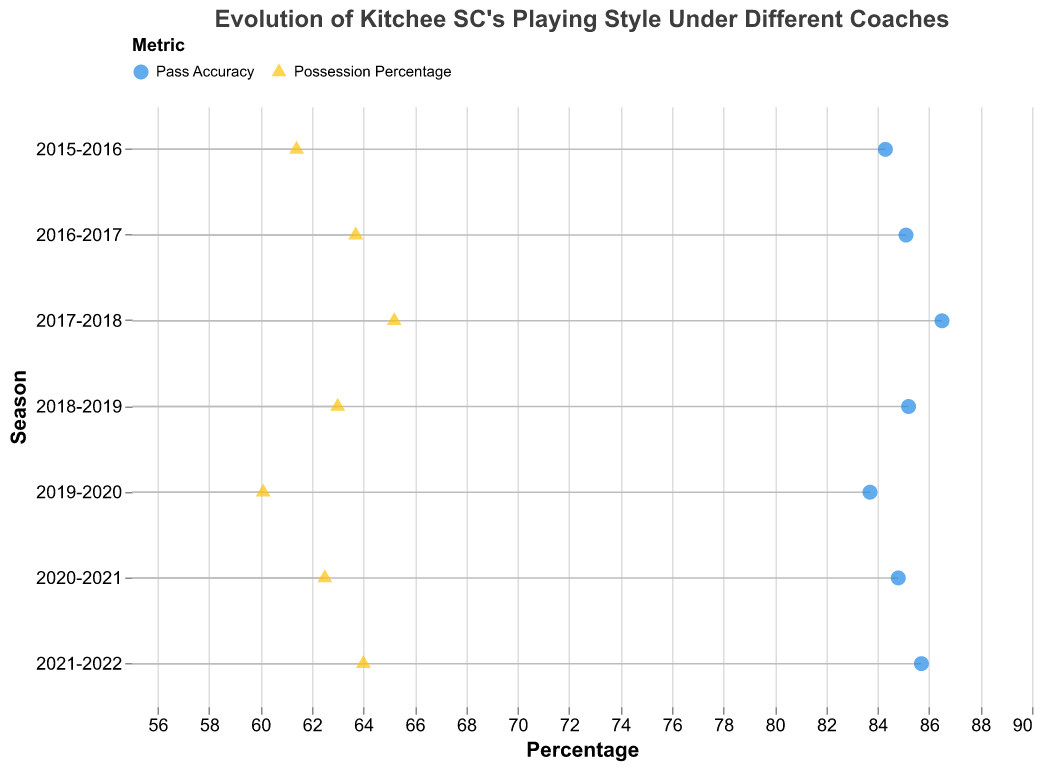What is the title of the figure? The title of a figure is usually found at the top and describes what the plot is about.
Answer: Evolution of Kitchee SC's Playing Style Under Different Coaches What are the two metrics visualized in the plot? From the legend or axis labels of the plot, we can identify the metrics being visualized.
Answer: Possession Percentage and Pass Accuracy In which season did Kitchee SC have the highest possession percentage, and who was the coach? Identify the data point with the highest possession percentage value and note the corresponding season and coach.
Answer: 2017-2018, Chu Chi Kwong What is the pass accuracy percentage for Alex Chu in the 2021-2022 season? Look at the data points for Alex Chu in the specified season and read the value corresponding to Pass Accuracy.
Answer: 85.7 Which season under Jose Molina had a higher possession percentage and by how much? Compare the possession percentages of two seasons under Jose Molina and calculate the difference.
Answer: 2016-2017, by 2.3 How did the possession percentage change from 2017-2018 to 2018-2019 under Chu Chi Kwong? Compare the possession percentages between the two seasons for Chu Chi Kwong and find the difference.
Answer: Decreased by 2.2 What is the average pass accuracy percentage across all seasons for Alex Chu? Find the pass accuracy values for all seasons under Alex Chu, sum them up, and divide by the number of seasons he coached. (83.7 + 84.8 + 85.7)/3
Answer: 84.7 Who had the highest pass accuracy percentage as a coach and what was the value? Identify the coach with the highest pass accuracy value by examining all data points.
Answer: Chu Chi Kwong, 86.5 Which metric, on average, had a higher value under Jose Molina's coaching? Calculate the average of both possession percentage and pass accuracy under Jose Molina and compare them. ((61.4 + 63.7)/2 vs. (84.3 + 85.1)/2)
Answer: Pass Accuracy Between which two consecutive seasons did the largest increase in possession percentage occur and what was the amount? Evaluate the difference in possession percentage between consecutive seasons and identify the maximum increase.
Answer: From 2019-2020 to 2020-2021, increased by 2.4 